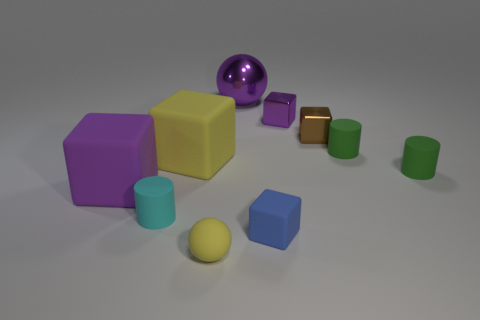What size is the shiny cube that is the same color as the shiny sphere?
Make the answer very short. Small. What is the shape of the tiny yellow object?
Your response must be concise. Sphere. What shape is the big purple object in front of the purple cube that is behind the brown thing?
Offer a very short reply. Cube. Is the tiny purple object that is right of the small cyan matte object made of the same material as the big yellow block?
Keep it short and to the point. No. What number of purple things are big shiny spheres or spheres?
Your response must be concise. 1. Are there any objects of the same color as the matte ball?
Your answer should be very brief. Yes. Are there any tiny brown blocks that have the same material as the yellow cube?
Give a very brief answer. No. There is a shiny thing that is both behind the small brown cube and on the right side of the blue block; what shape is it?
Your answer should be very brief. Cube. What number of big objects are yellow matte blocks or rubber objects?
Provide a succinct answer. 2. What is the material of the small brown block?
Keep it short and to the point. Metal. 